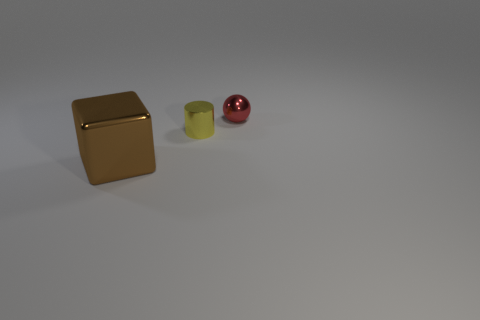Do the brown thing and the yellow cylinder have the same size?
Give a very brief answer. No. How many other objects are the same shape as the yellow thing?
Make the answer very short. 0. What material is the thing behind the tiny metal thing in front of the red thing?
Your answer should be compact. Metal. There is a shiny block; are there any shiny cylinders behind it?
Your response must be concise. Yes. Does the yellow cylinder have the same size as the shiny object in front of the tiny yellow metal cylinder?
Ensure brevity in your answer.  No. Does the metallic thing that is in front of the yellow metallic cylinder have the same size as the metal object that is on the right side of the tiny yellow cylinder?
Provide a short and direct response. No. What number of tiny objects are brown matte blocks or shiny balls?
Make the answer very short. 1. How many things are both in front of the tiny red metal thing and on the right side of the large brown metallic object?
Make the answer very short. 1. What number of brown objects are either small metal cubes or cylinders?
Your answer should be compact. 0. Are there any red shiny balls that have the same size as the yellow object?
Ensure brevity in your answer.  Yes. 